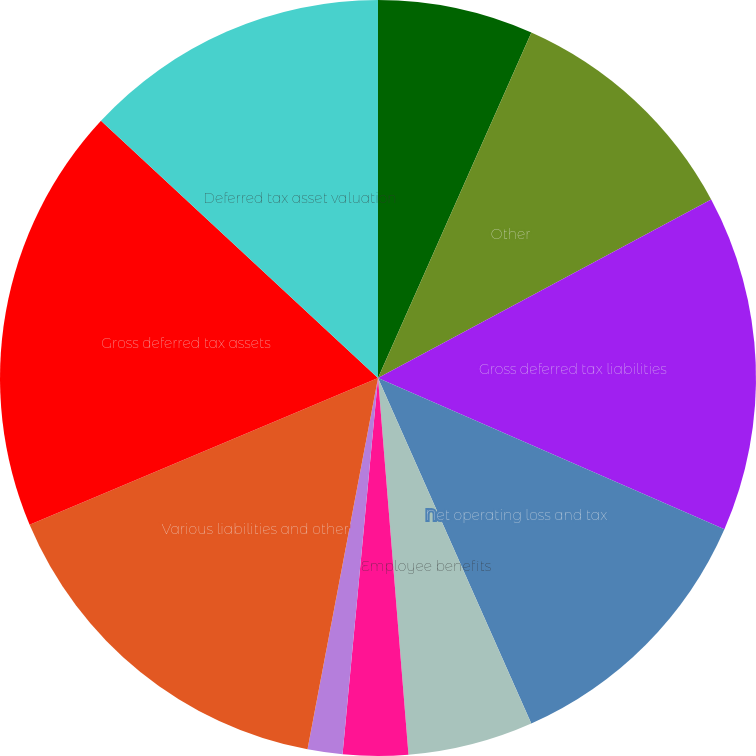<chart> <loc_0><loc_0><loc_500><loc_500><pie_chart><fcel>Intangible assets and property<fcel>Other<fcel>Gross deferred tax liabilities<fcel>Net operating loss and tax<fcel>Employee benefits<fcel>Self-insured casualty claims<fcel>Capital leases and future rent<fcel>Various liabilities and other<fcel>Gross deferred tax assets<fcel>Deferred tax asset valuation<nl><fcel>6.65%<fcel>10.52%<fcel>14.38%<fcel>11.8%<fcel>5.36%<fcel>2.78%<fcel>1.49%<fcel>15.67%<fcel>18.25%<fcel>13.09%<nl></chart> 